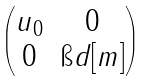Convert formula to latex. <formula><loc_0><loc_0><loc_500><loc_500>\begin{pmatrix} u _ { 0 } & 0 \\ 0 & \i d [ m ] \end{pmatrix}</formula> 